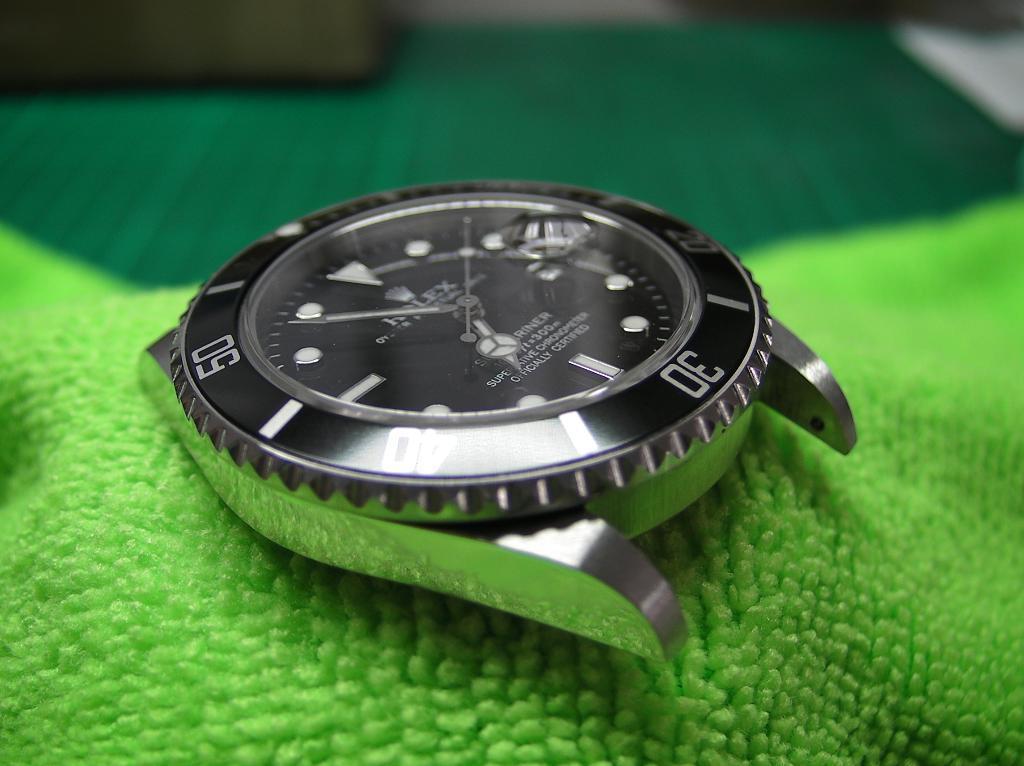Could you give a brief overview of what you see in this image? In this picture we can see a watch. 